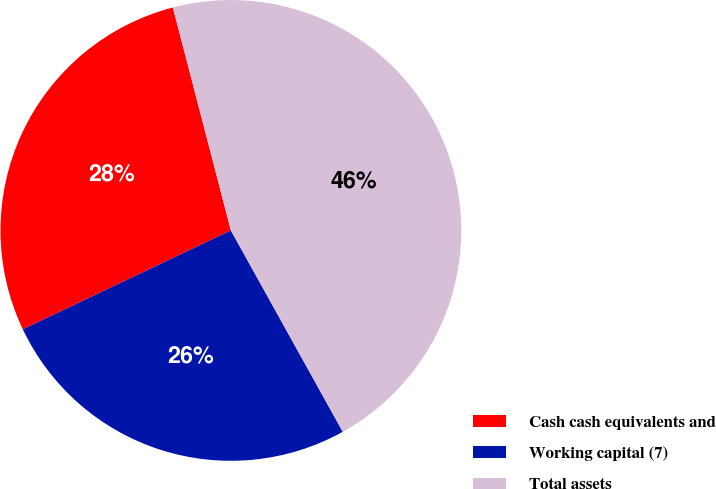Convert chart. <chart><loc_0><loc_0><loc_500><loc_500><pie_chart><fcel>Cash cash equivalents and<fcel>Working capital (7)<fcel>Total assets<nl><fcel>28.01%<fcel>26.01%<fcel>45.98%<nl></chart> 